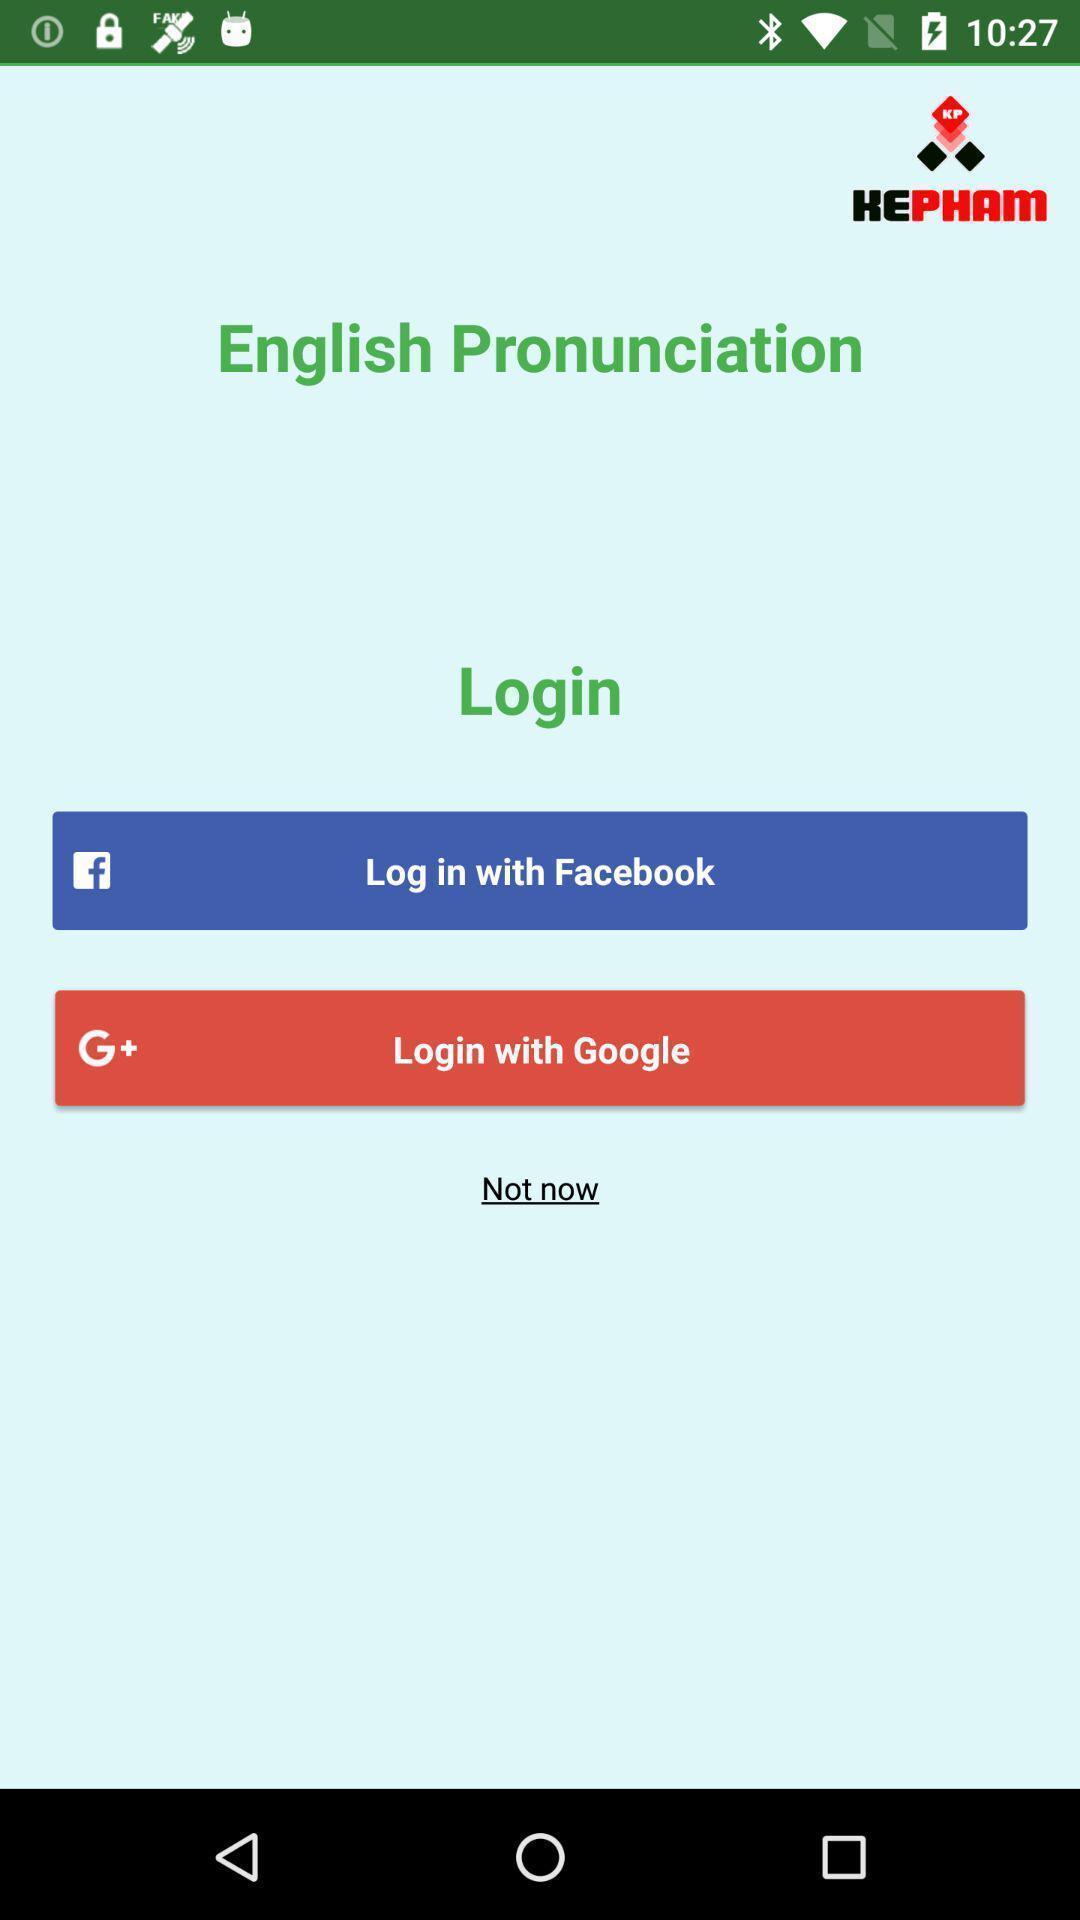Describe the key features of this screenshot. Page asking to login with an social app. 